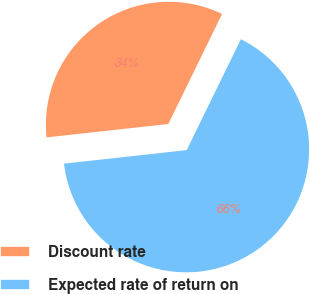<chart> <loc_0><loc_0><loc_500><loc_500><pie_chart><fcel>Discount rate<fcel>Expected rate of return on<nl><fcel>33.98%<fcel>66.02%<nl></chart> 